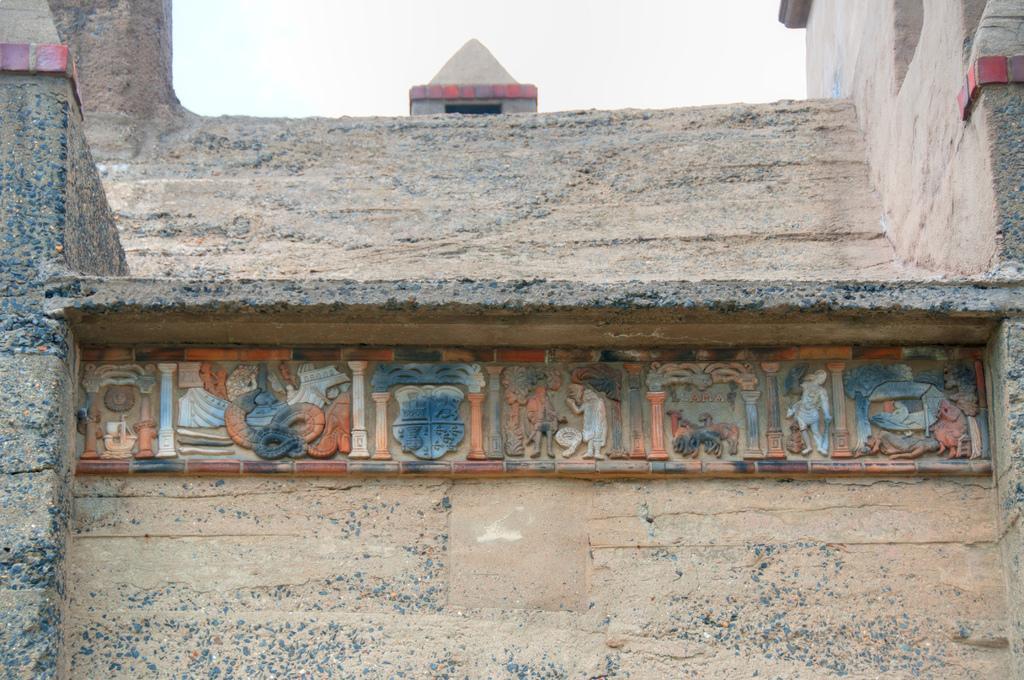In one or two sentences, can you explain what this image depicts? In this image there is the wall, at the top there is the sky, on the wall there is an art visible. 